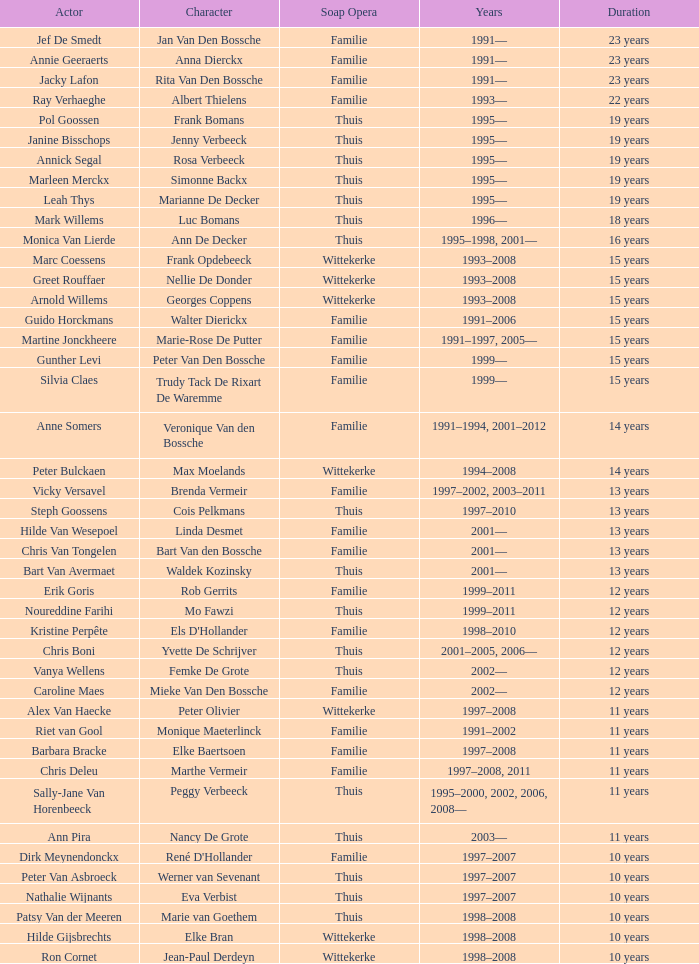What was the character vicky versavel played for a period of 13 years? Brenda Vermeir. 